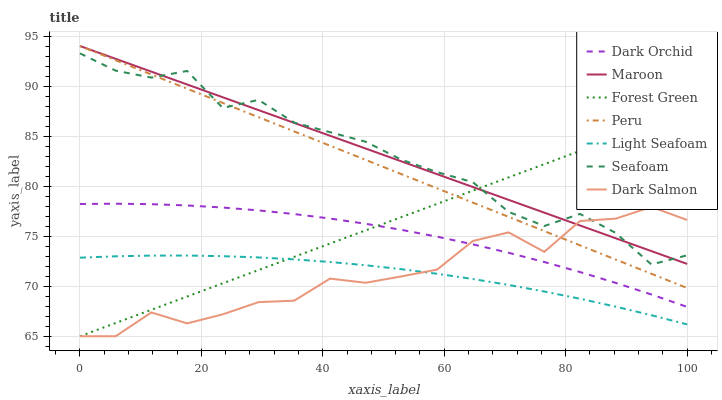Does Light Seafoam have the minimum area under the curve?
Answer yes or no. Yes. Does Maroon have the maximum area under the curve?
Answer yes or no. Yes. Does Dark Salmon have the minimum area under the curve?
Answer yes or no. No. Does Dark Salmon have the maximum area under the curve?
Answer yes or no. No. Is Maroon the smoothest?
Answer yes or no. Yes. Is Dark Salmon the roughest?
Answer yes or no. Yes. Is Dark Salmon the smoothest?
Answer yes or no. No. Is Maroon the roughest?
Answer yes or no. No. Does Maroon have the lowest value?
Answer yes or no. No. Does Dark Salmon have the highest value?
Answer yes or no. No. Is Dark Orchid less than Maroon?
Answer yes or no. Yes. Is Peru greater than Light Seafoam?
Answer yes or no. Yes. Does Dark Orchid intersect Maroon?
Answer yes or no. No. 